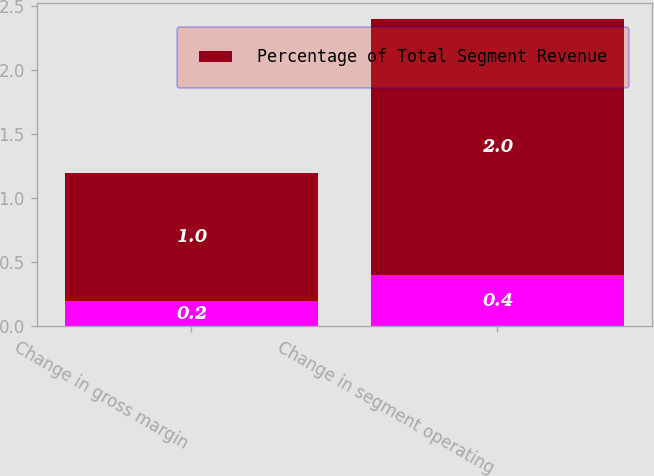<chart> <loc_0><loc_0><loc_500><loc_500><stacked_bar_chart><ecel><fcel>Change in gross margin<fcel>Change in segment operating<nl><fcel>nan<fcel>0.2<fcel>0.4<nl><fcel>Percentage of Total Segment Revenue<fcel>1<fcel>2<nl></chart> 